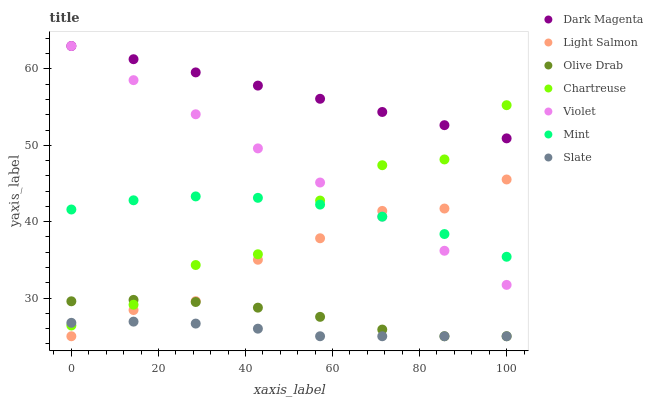Does Slate have the minimum area under the curve?
Answer yes or no. Yes. Does Dark Magenta have the maximum area under the curve?
Answer yes or no. Yes. Does Dark Magenta have the minimum area under the curve?
Answer yes or no. No. Does Slate have the maximum area under the curve?
Answer yes or no. No. Is Violet the smoothest?
Answer yes or no. Yes. Is Chartreuse the roughest?
Answer yes or no. Yes. Is Dark Magenta the smoothest?
Answer yes or no. No. Is Dark Magenta the roughest?
Answer yes or no. No. Does Light Salmon have the lowest value?
Answer yes or no. Yes. Does Dark Magenta have the lowest value?
Answer yes or no. No. Does Violet have the highest value?
Answer yes or no. Yes. Does Slate have the highest value?
Answer yes or no. No. Is Slate less than Mint?
Answer yes or no. Yes. Is Dark Magenta greater than Olive Drab?
Answer yes or no. Yes. Does Mint intersect Violet?
Answer yes or no. Yes. Is Mint less than Violet?
Answer yes or no. No. Is Mint greater than Violet?
Answer yes or no. No. Does Slate intersect Mint?
Answer yes or no. No. 